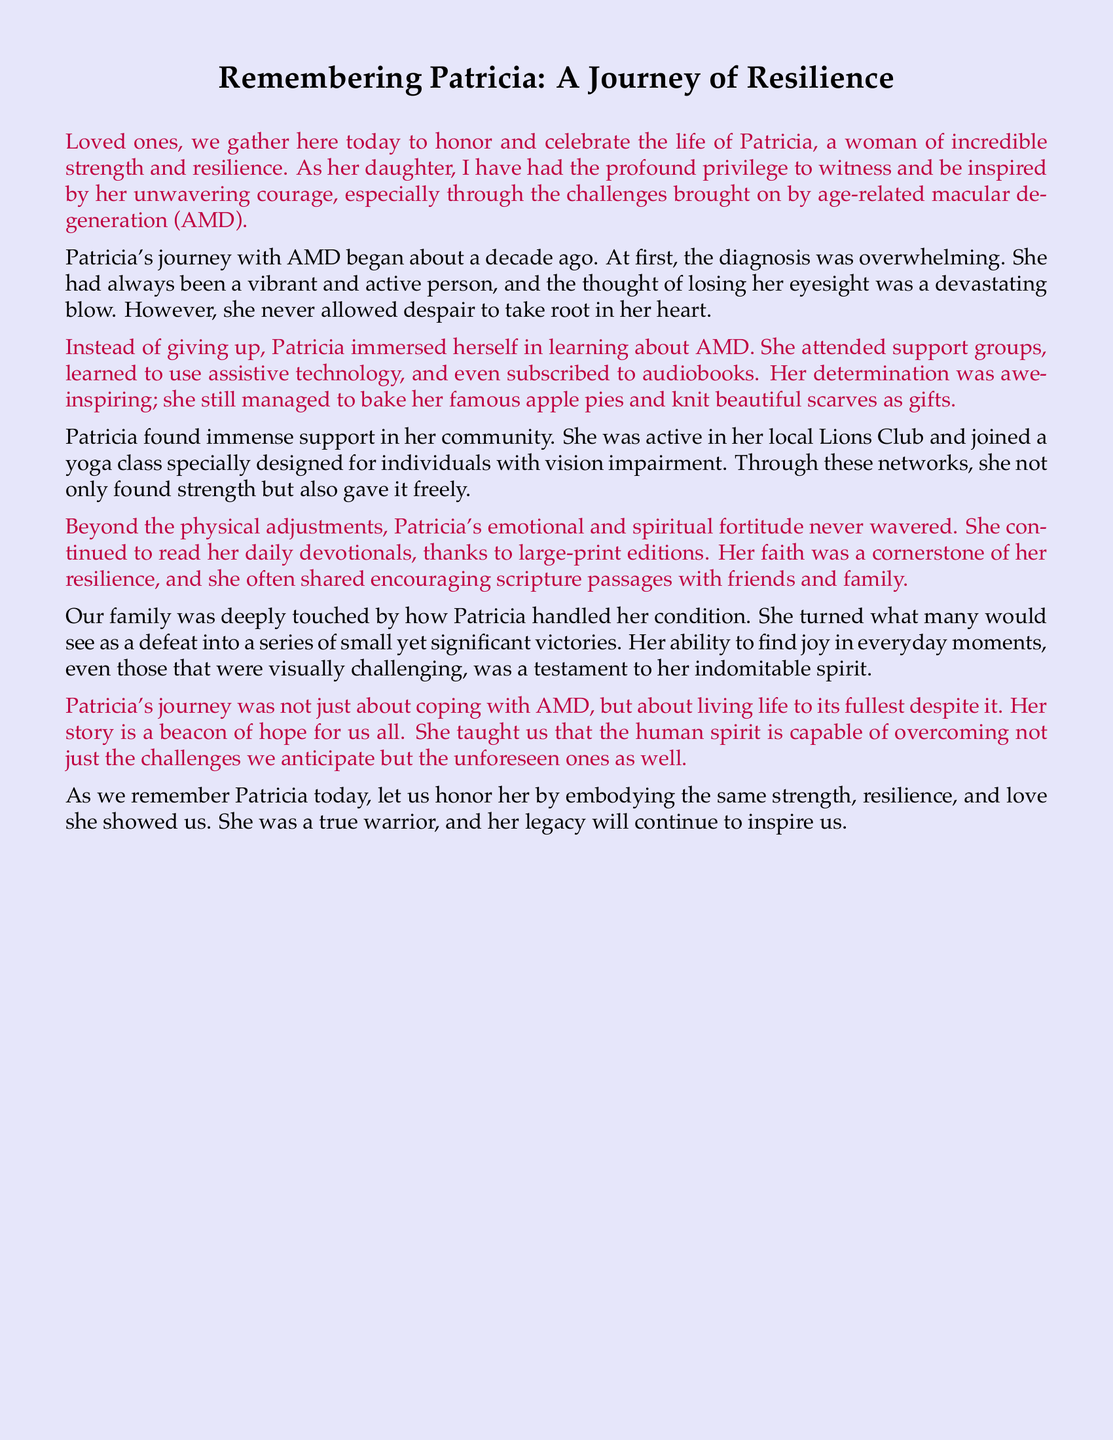What was Patricia's condition? The document states that Patricia faced challenges due to age-related macular degeneration.
Answer: age-related macular degeneration How long ago did Patricia's journey with AMD begin? The document mentions that Patricia's journey with AMD began about a decade ago.
Answer: about a decade ago What activity did Patricia continue to do despite her condition? The eulogy describes how Patricia managed to bake her famous apple pies despite her challenges.
Answer: bake apple pies Which community group was mentioned in connection to Patricia? The eulogy highlights Patricia's involvement in her local Lions Club for support.
Answer: Lions Club What was a source of emotional support for Patricia? The document indicates that Patricia found strength through her faith and daily devotionals.
Answer: her faith How did Patricia adapt to her vision impairment? It is stated that Patricia learned to use assistive technology to cope with her AMD.
Answer: assistive technology What trait of Patricia's spirit is emphasized in her journey? The eulogy emphasizes Patricia's resilience throughout her challenges with AMD.
Answer: resilience What is the overall theme of Patricia's story in the eulogy? The journey is described as a beacon of hope and living life to its fullest despite challenges.
Answer: beacon of hope 